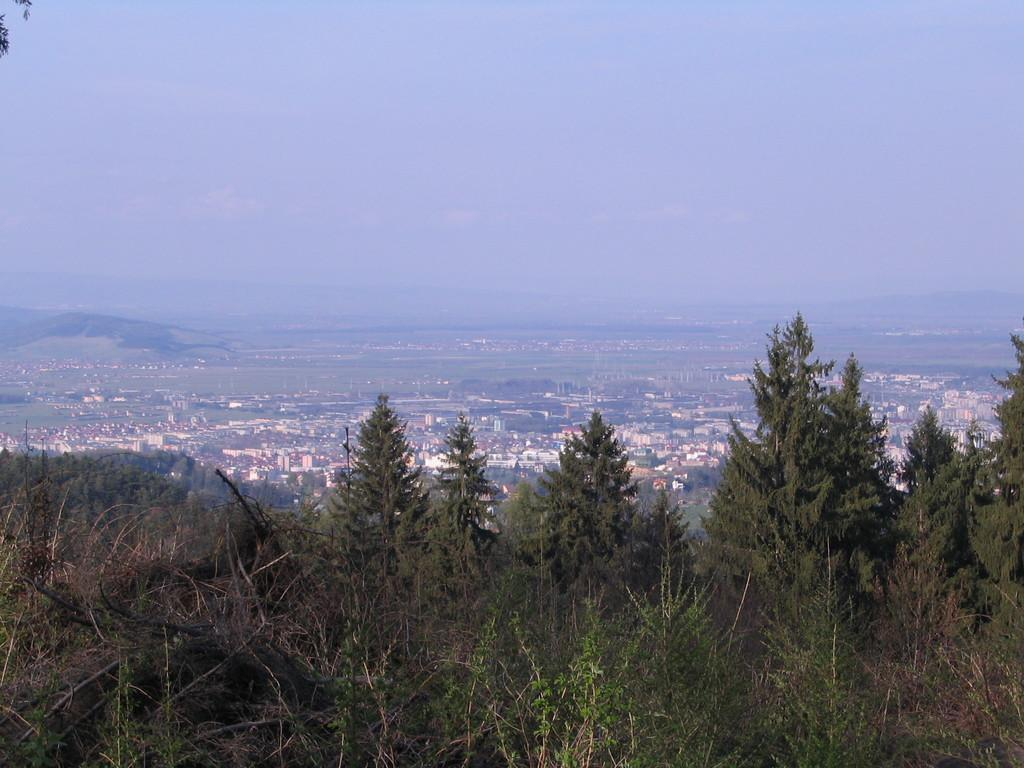What is located in the foreground of the image? There are trees in the foreground of the image. What can be seen in the middle of the image? There are buildings and trees in the middle of the image. What is visible at the top of the image? The sky is visible at the top of the image. How many tomatoes are hanging from the trees in the image? There are no tomatoes present in the image; it features trees, buildings, and the sky. What riddle is being solved by the bird in the image? There is no bird or riddle present in the image. 